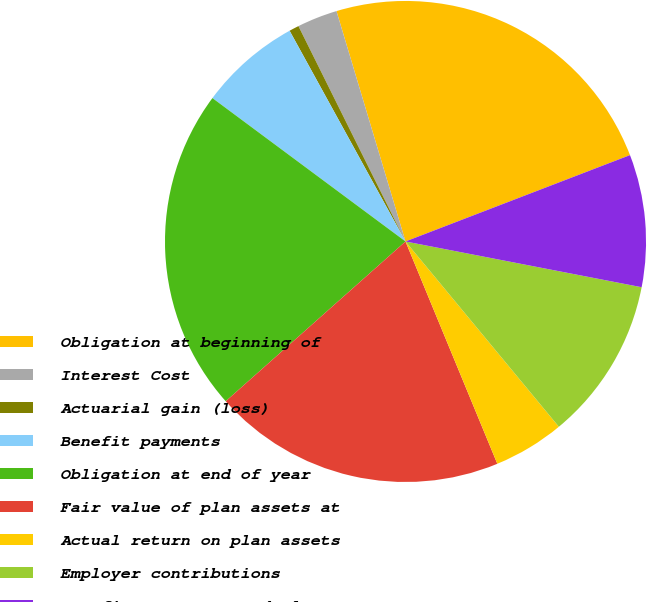<chart> <loc_0><loc_0><loc_500><loc_500><pie_chart><fcel>Obligation at beginning of<fcel>Interest Cost<fcel>Actuarial gain (loss)<fcel>Benefit payments<fcel>Obligation at end of year<fcel>Fair value of plan assets at<fcel>Actual return on plan assets<fcel>Employer contributions<fcel>Benefits payments and plan<nl><fcel>23.79%<fcel>2.71%<fcel>0.66%<fcel>6.83%<fcel>21.73%<fcel>19.67%<fcel>4.77%<fcel>10.95%<fcel>8.89%<nl></chart> 